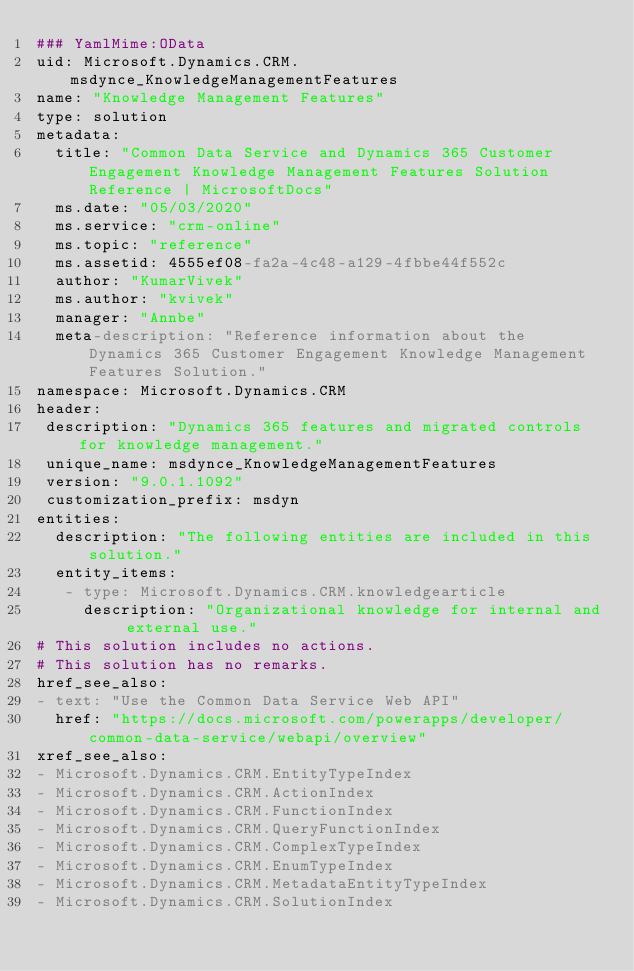Convert code to text. <code><loc_0><loc_0><loc_500><loc_500><_YAML_>### YamlMime:OData
uid: Microsoft.Dynamics.CRM.msdynce_KnowledgeManagementFeatures
name: "Knowledge Management Features"
type: solution
metadata: 
  title: "Common Data Service and Dynamics 365 Customer Engagement Knowledge Management Features Solution Reference | MicrosoftDocs"
  ms.date: "05/03/2020"
  ms.service: "crm-online"
  ms.topic: "reference"
  ms.assetid: 4555ef08-fa2a-4c48-a129-4fbbe44f552c
  author: "KumarVivek"
  ms.author: "kvivek"
  manager: "Annbe"
  meta-description: "Reference information about the Dynamics 365 Customer Engagement Knowledge Management Features Solution."
namespace: Microsoft.Dynamics.CRM
header:
 description: "Dynamics 365 features and migrated controls for knowledge management."
 unique_name: msdynce_KnowledgeManagementFeatures
 version: "9.0.1.1092"
 customization_prefix: msdyn
entities:
  description: "The following entities are included in this solution."
  entity_items:
   - type: Microsoft.Dynamics.CRM.knowledgearticle
     description: "Organizational knowledge for internal and external use."
# This solution includes no actions.
# This solution has no remarks.
href_see_also:
- text: "Use the Common Data Service Web API"
  href: "https://docs.microsoft.com/powerapps/developer/common-data-service/webapi/overview"
xref_see_also:
- Microsoft.Dynamics.CRM.EntityTypeIndex
- Microsoft.Dynamics.CRM.ActionIndex
- Microsoft.Dynamics.CRM.FunctionIndex
- Microsoft.Dynamics.CRM.QueryFunctionIndex
- Microsoft.Dynamics.CRM.ComplexTypeIndex
- Microsoft.Dynamics.CRM.EnumTypeIndex
- Microsoft.Dynamics.CRM.MetadataEntityTypeIndex
- Microsoft.Dynamics.CRM.SolutionIndex</code> 